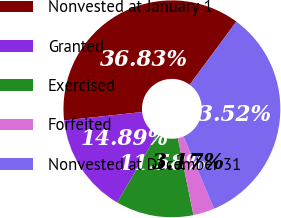Convert chart to OTSL. <chart><loc_0><loc_0><loc_500><loc_500><pie_chart><fcel>Nonvested at January 1<fcel>Granted<fcel>Exercised<fcel>Forfeited<fcel>Nonvested at December 31<nl><fcel>36.83%<fcel>14.89%<fcel>11.58%<fcel>3.17%<fcel>33.52%<nl></chart> 